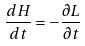Convert formula to latex. <formula><loc_0><loc_0><loc_500><loc_500>\frac { d H } { d t } = - \frac { \partial L } { \partial t }</formula> 